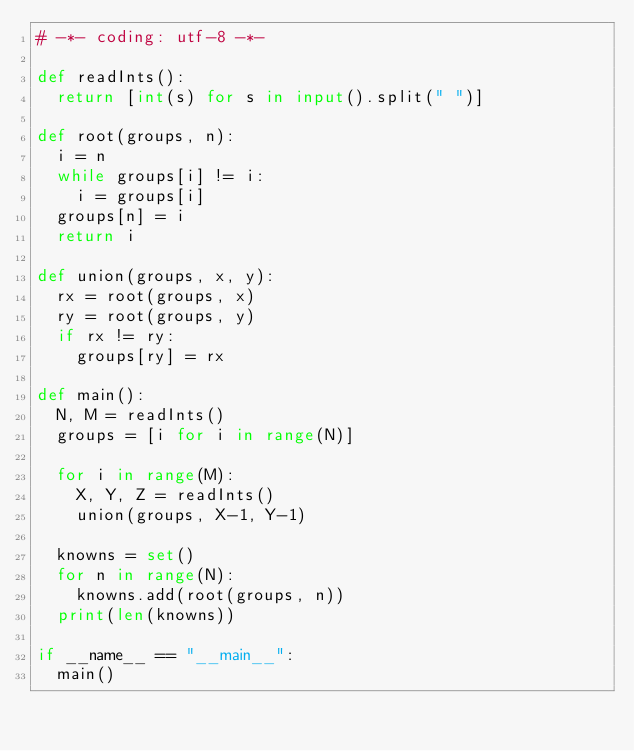<code> <loc_0><loc_0><loc_500><loc_500><_Python_># -*- coding: utf-8 -*-

def readInts():
  return [int(s) for s in input().split(" ")]

def root(groups, n):
  i = n
  while groups[i] != i:
    i = groups[i]
  groups[n] = i
  return i

def union(groups, x, y):
  rx = root(groups, x)
  ry = root(groups, y)
  if rx != ry:
    groups[ry] = rx

def main():
  N, M = readInts()
  groups = [i for i in range(N)]

  for i in range(M):
    X, Y, Z = readInts()
    union(groups, X-1, Y-1)

  knowns = set()
  for n in range(N):
    knowns.add(root(groups, n))
  print(len(knowns))

if __name__ == "__main__":
  main()
</code> 